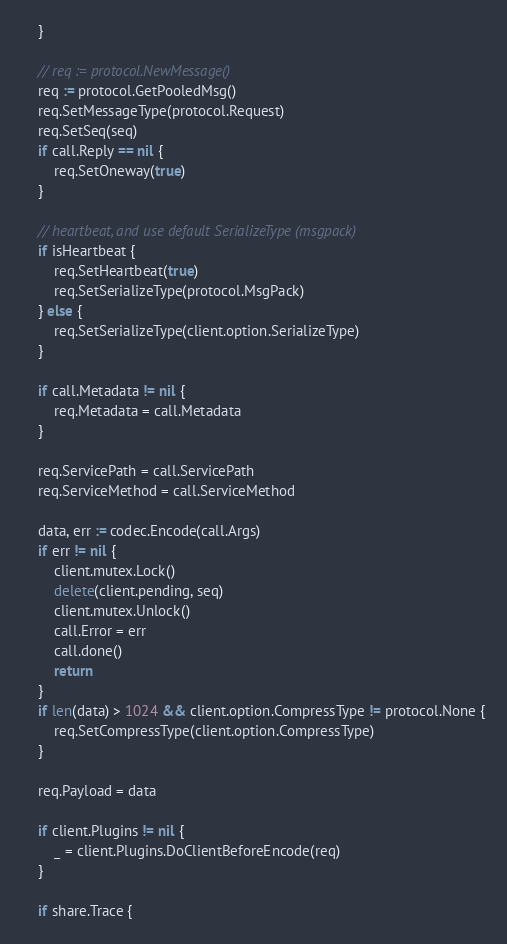<code> <loc_0><loc_0><loc_500><loc_500><_Go_>	}

	// req := protocol.NewMessage()
	req := protocol.GetPooledMsg()
	req.SetMessageType(protocol.Request)
	req.SetSeq(seq)
	if call.Reply == nil {
		req.SetOneway(true)
	}

	// heartbeat, and use default SerializeType (msgpack)
	if isHeartbeat {
		req.SetHeartbeat(true)
		req.SetSerializeType(protocol.MsgPack)
	} else {
		req.SetSerializeType(client.option.SerializeType)
	}

	if call.Metadata != nil {
		req.Metadata = call.Metadata
	}

	req.ServicePath = call.ServicePath
	req.ServiceMethod = call.ServiceMethod

	data, err := codec.Encode(call.Args)
	if err != nil {
		client.mutex.Lock()
		delete(client.pending, seq)
		client.mutex.Unlock()
		call.Error = err
		call.done()
		return
	}
	if len(data) > 1024 && client.option.CompressType != protocol.None {
		req.SetCompressType(client.option.CompressType)
	}

	req.Payload = data

	if client.Plugins != nil {
		_ = client.Plugins.DoClientBeforeEncode(req)
	}

	if share.Trace {</code> 